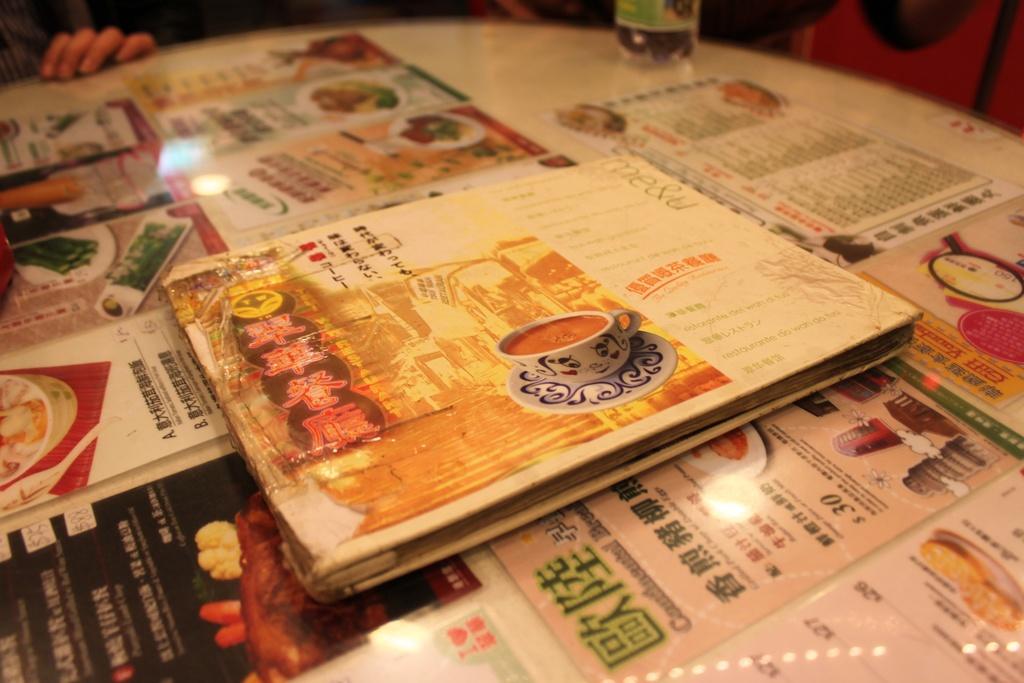How much does a plate of food cost?
Your response must be concise. $30. 